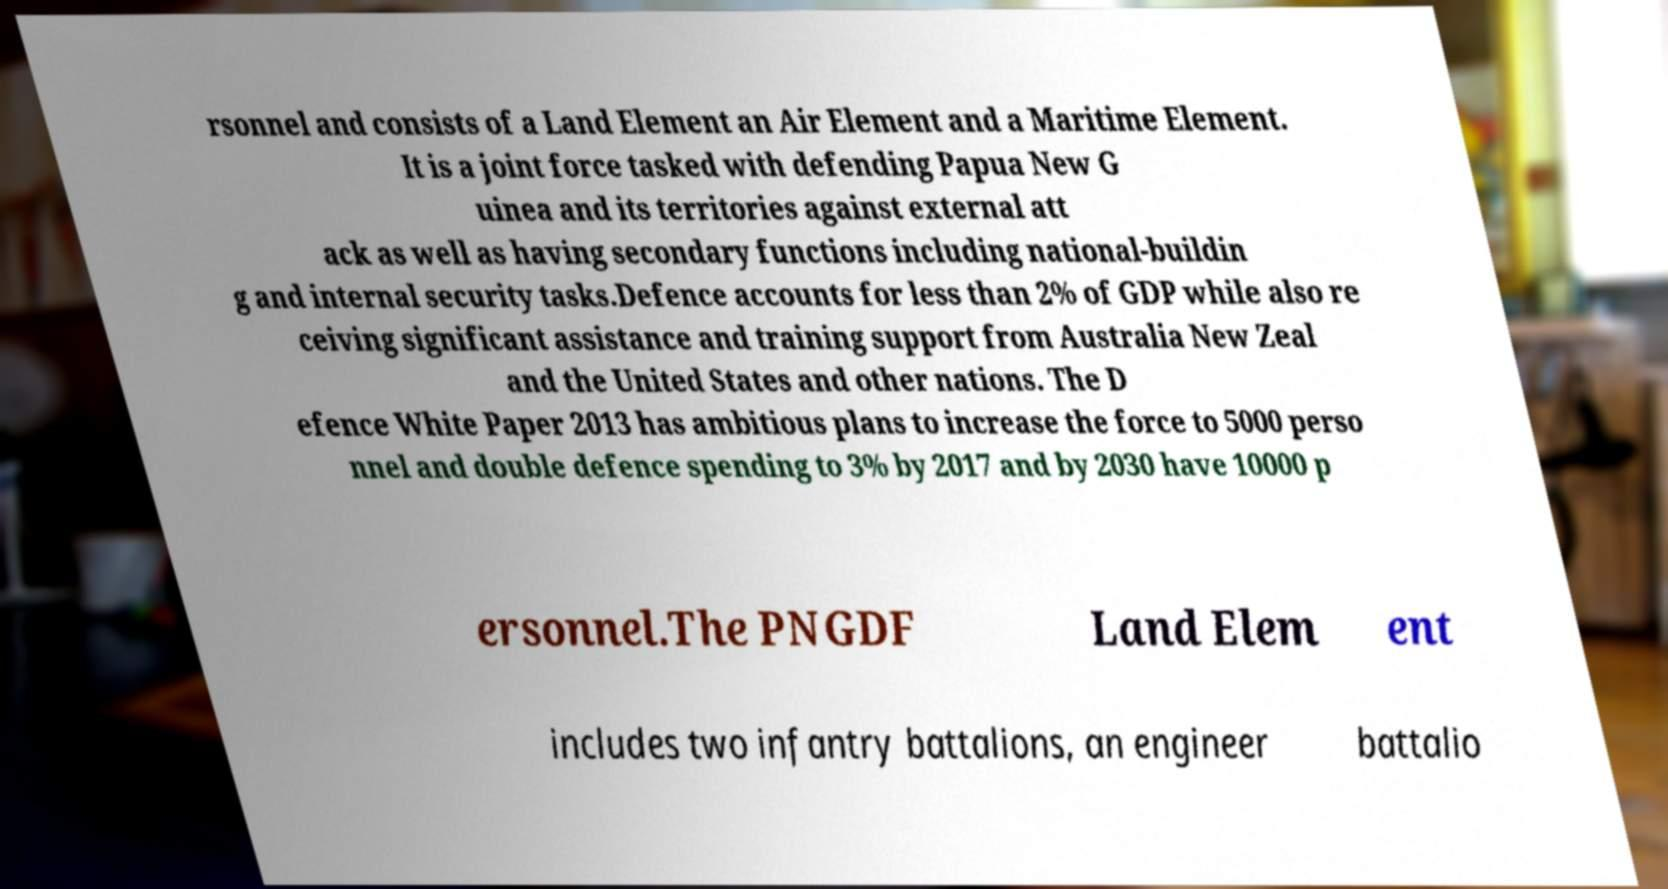For documentation purposes, I need the text within this image transcribed. Could you provide that? rsonnel and consists of a Land Element an Air Element and a Maritime Element. It is a joint force tasked with defending Papua New G uinea and its territories against external att ack as well as having secondary functions including national-buildin g and internal security tasks.Defence accounts for less than 2% of GDP while also re ceiving significant assistance and training support from Australia New Zeal and the United States and other nations. The D efence White Paper 2013 has ambitious plans to increase the force to 5000 perso nnel and double defence spending to 3% by 2017 and by 2030 have 10000 p ersonnel.The PNGDF Land Elem ent includes two infantry battalions, an engineer battalio 